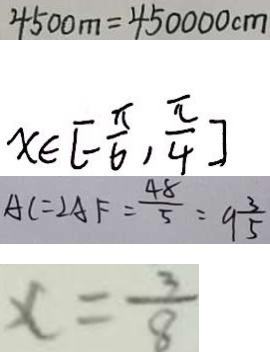Convert formula to latex. <formula><loc_0><loc_0><loc_500><loc_500>4 5 0 0 m = 4 5 0 0 0 0 c m 
 x \in [ - \frac { \pi } { 6 } , \frac { \pi } { 4 } ] 
 A C = 2 A F = \frac { 4 8 } { 5 } = 9 \frac { 3 } { 5 } 
 x = \frac { 3 } { 8 }</formula> 